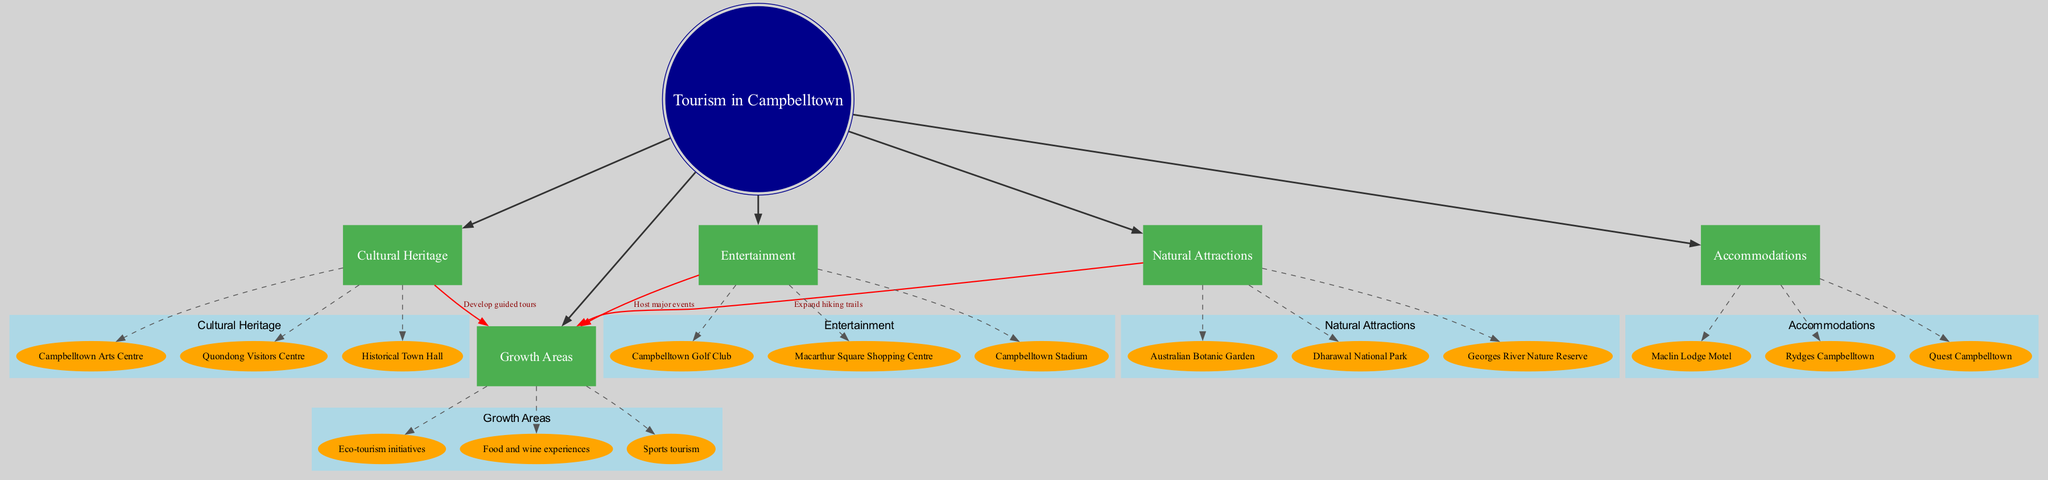How many main categories are there related to tourism in Campbelltown? The diagram lists five main categories directly connected to the central node "Tourism in Campbelltown". These categories are depicted as individual nodes branching out from the central node.
Answer: 5 What are the subcategories under "Natural Attractions"? The subcategories of "Natural Attractions" include three specific locations: "Australian Botanic Garden", "Dharawal National Park", and "Georges River Nature Reserve". These locations are represented as nodes below the "Natural Attractions" node.
Answer: Australian Botanic Garden, Dharawal National Park, Georges River Nature Reserve Which category has connections to "Growth Areas"? The "Natural Attractions", "Cultural Heritage", and "Entertainment" categories all have connections to "Growth Areas", indicating potential development opportunities. Each connection is marked with a specific label describing the proposed growth action, connecting these categories to the growth area node.
Answer: Natural Attractions, Cultural Heritage, Entertainment What is the proposed growth area related to "Cultural Heritage"? The connection from "Cultural Heritage" to "Growth Areas" is labeled "Develop guided tours". This indicates that this specific aspect of tourism is being considered for potential growth through the establishment of guided tours.
Answer: Develop guided tours How many subcategories are there under "Entertainment"? Under the "Entertainment" category, there are three subcategories listed: "Macarthur Square Shopping Centre", "Campbelltown Stadium", and "Campbelltown Golf Club". This is determined by counting the nodes associated with the "Entertainment" category on the diagram.
Answer: 3 What action is suggested to enhance "Natural Attractions"? The label on the connection from "Natural Attractions" to "Growth Areas" states "Expand hiking trails", indicating the suggested action aimed at better utilization or enhancement of the natural attractions available.
Answer: Expand hiking trails Which accommodation option is mentioned in the diagram? The diagram includes three accommodation options: "Rydges Campbelltown", "Quest Campbelltown", and "Maclin Lodge Motel". These are clearly labeled as subcategories under the "Accommodations" category in the diagram.
Answer: Rydges Campbelltown, Quest Campbelltown, Maclin Lodge Motel Which growth area is linked to "Sports tourism"? Among the listed growth areas, one is specifically "Sports tourism", indicating an area identified for potential development in tourism related to sports activities. This information can be found directly as a subcategory of "Growth Areas".
Answer: Sports tourism What is the connection between "Entertainment" and "Growth Areas"? The diagram indicates that the connection from "Entertainment" to "Growth Areas" is labeled "Host major events". This suggests a specific strategy to leverage entertainment venues for increased tourism growth.
Answer: Host major events 